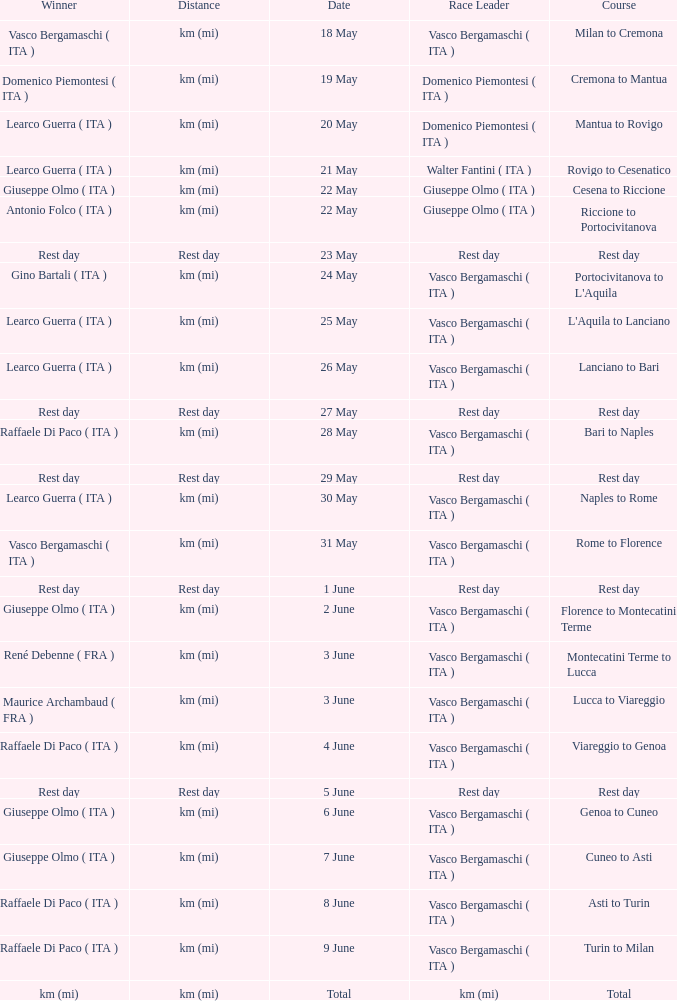Who won on 28 May? Raffaele Di Paco ( ITA ). 